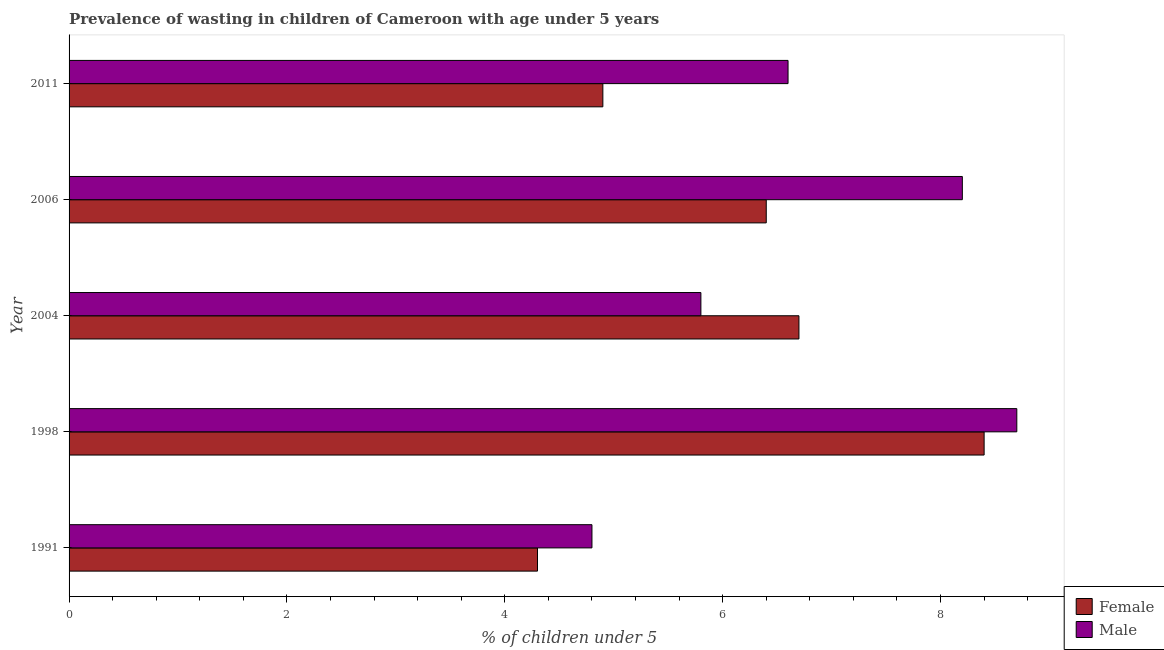How many different coloured bars are there?
Your response must be concise. 2. How many groups of bars are there?
Your answer should be compact. 5. Are the number of bars on each tick of the Y-axis equal?
Your answer should be compact. Yes. How many bars are there on the 5th tick from the top?
Your response must be concise. 2. What is the percentage of undernourished male children in 1998?
Offer a very short reply. 8.7. Across all years, what is the maximum percentage of undernourished female children?
Your answer should be very brief. 8.4. Across all years, what is the minimum percentage of undernourished female children?
Keep it short and to the point. 4.3. What is the total percentage of undernourished male children in the graph?
Your answer should be very brief. 34.1. What is the difference between the percentage of undernourished female children in 1991 and that in 2004?
Your response must be concise. -2.4. What is the difference between the percentage of undernourished female children in 1998 and the percentage of undernourished male children in 2006?
Make the answer very short. 0.2. What is the average percentage of undernourished female children per year?
Offer a very short reply. 6.14. What is the ratio of the percentage of undernourished male children in 1991 to that in 2006?
Offer a very short reply. 0.58. Is the percentage of undernourished female children in 1998 less than that in 2011?
Offer a very short reply. No. Is the difference between the percentage of undernourished female children in 1998 and 2004 greater than the difference between the percentage of undernourished male children in 1998 and 2004?
Keep it short and to the point. No. What is the difference between the highest and the second highest percentage of undernourished male children?
Ensure brevity in your answer.  0.5. What is the difference between the highest and the lowest percentage of undernourished male children?
Offer a very short reply. 3.9. Is the sum of the percentage of undernourished male children in 1998 and 2011 greater than the maximum percentage of undernourished female children across all years?
Your answer should be compact. Yes. What does the 1st bar from the top in 1998 represents?
Your response must be concise. Male. What does the 2nd bar from the bottom in 2006 represents?
Your answer should be compact. Male. How many bars are there?
Provide a succinct answer. 10. Are all the bars in the graph horizontal?
Your answer should be very brief. Yes. Are the values on the major ticks of X-axis written in scientific E-notation?
Provide a short and direct response. No. Does the graph contain grids?
Offer a very short reply. No. How many legend labels are there?
Offer a terse response. 2. How are the legend labels stacked?
Give a very brief answer. Vertical. What is the title of the graph?
Give a very brief answer. Prevalence of wasting in children of Cameroon with age under 5 years. What is the label or title of the X-axis?
Offer a terse response.  % of children under 5. What is the label or title of the Y-axis?
Keep it short and to the point. Year. What is the  % of children under 5 of Female in 1991?
Your response must be concise. 4.3. What is the  % of children under 5 of Male in 1991?
Offer a terse response. 4.8. What is the  % of children under 5 in Female in 1998?
Your response must be concise. 8.4. What is the  % of children under 5 in Male in 1998?
Provide a short and direct response. 8.7. What is the  % of children under 5 of Female in 2004?
Your answer should be very brief. 6.7. What is the  % of children under 5 in Male in 2004?
Your response must be concise. 5.8. What is the  % of children under 5 in Female in 2006?
Offer a terse response. 6.4. What is the  % of children under 5 in Male in 2006?
Keep it short and to the point. 8.2. What is the  % of children under 5 of Female in 2011?
Ensure brevity in your answer.  4.9. What is the  % of children under 5 in Male in 2011?
Offer a very short reply. 6.6. Across all years, what is the maximum  % of children under 5 in Female?
Your answer should be compact. 8.4. Across all years, what is the maximum  % of children under 5 of Male?
Your answer should be compact. 8.7. Across all years, what is the minimum  % of children under 5 in Female?
Ensure brevity in your answer.  4.3. Across all years, what is the minimum  % of children under 5 in Male?
Your response must be concise. 4.8. What is the total  % of children under 5 of Female in the graph?
Offer a very short reply. 30.7. What is the total  % of children under 5 of Male in the graph?
Keep it short and to the point. 34.1. What is the difference between the  % of children under 5 of Female in 1991 and that in 1998?
Your answer should be very brief. -4.1. What is the difference between the  % of children under 5 of Female in 1991 and that in 2004?
Ensure brevity in your answer.  -2.4. What is the difference between the  % of children under 5 in Male in 1991 and that in 2004?
Offer a very short reply. -1. What is the difference between the  % of children under 5 in Male in 1991 and that in 2006?
Offer a terse response. -3.4. What is the difference between the  % of children under 5 of Female in 1991 and that in 2011?
Offer a terse response. -0.6. What is the difference between the  % of children under 5 of Male in 1991 and that in 2011?
Provide a short and direct response. -1.8. What is the difference between the  % of children under 5 of Female in 1998 and that in 2004?
Offer a terse response. 1.7. What is the difference between the  % of children under 5 in Male in 1998 and that in 2004?
Make the answer very short. 2.9. What is the difference between the  % of children under 5 of Female in 1998 and that in 2006?
Keep it short and to the point. 2. What is the difference between the  % of children under 5 in Female in 1998 and that in 2011?
Provide a succinct answer. 3.5. What is the difference between the  % of children under 5 in Male in 1998 and that in 2011?
Give a very brief answer. 2.1. What is the difference between the  % of children under 5 of Female in 2004 and that in 2006?
Your answer should be very brief. 0.3. What is the difference between the  % of children under 5 of Male in 2004 and that in 2006?
Keep it short and to the point. -2.4. What is the difference between the  % of children under 5 in Male in 2004 and that in 2011?
Ensure brevity in your answer.  -0.8. What is the difference between the  % of children under 5 of Female in 1991 and the  % of children under 5 of Male in 1998?
Keep it short and to the point. -4.4. What is the difference between the  % of children under 5 in Female in 1998 and the  % of children under 5 in Male in 2004?
Give a very brief answer. 2.6. What is the difference between the  % of children under 5 of Female in 1998 and the  % of children under 5 of Male in 2006?
Your answer should be very brief. 0.2. What is the difference between the  % of children under 5 of Female in 1998 and the  % of children under 5 of Male in 2011?
Your response must be concise. 1.8. What is the difference between the  % of children under 5 of Female in 2006 and the  % of children under 5 of Male in 2011?
Offer a very short reply. -0.2. What is the average  % of children under 5 in Female per year?
Provide a short and direct response. 6.14. What is the average  % of children under 5 of Male per year?
Your response must be concise. 6.82. In the year 2004, what is the difference between the  % of children under 5 in Female and  % of children under 5 in Male?
Your answer should be very brief. 0.9. In the year 2011, what is the difference between the  % of children under 5 in Female and  % of children under 5 in Male?
Offer a very short reply. -1.7. What is the ratio of the  % of children under 5 in Female in 1991 to that in 1998?
Provide a succinct answer. 0.51. What is the ratio of the  % of children under 5 in Male in 1991 to that in 1998?
Your answer should be compact. 0.55. What is the ratio of the  % of children under 5 of Female in 1991 to that in 2004?
Make the answer very short. 0.64. What is the ratio of the  % of children under 5 of Male in 1991 to that in 2004?
Give a very brief answer. 0.83. What is the ratio of the  % of children under 5 of Female in 1991 to that in 2006?
Give a very brief answer. 0.67. What is the ratio of the  % of children under 5 in Male in 1991 to that in 2006?
Offer a very short reply. 0.59. What is the ratio of the  % of children under 5 of Female in 1991 to that in 2011?
Provide a succinct answer. 0.88. What is the ratio of the  % of children under 5 in Male in 1991 to that in 2011?
Offer a terse response. 0.73. What is the ratio of the  % of children under 5 in Female in 1998 to that in 2004?
Offer a very short reply. 1.25. What is the ratio of the  % of children under 5 in Female in 1998 to that in 2006?
Your answer should be compact. 1.31. What is the ratio of the  % of children under 5 of Male in 1998 to that in 2006?
Provide a short and direct response. 1.06. What is the ratio of the  % of children under 5 of Female in 1998 to that in 2011?
Your response must be concise. 1.71. What is the ratio of the  % of children under 5 of Male in 1998 to that in 2011?
Give a very brief answer. 1.32. What is the ratio of the  % of children under 5 of Female in 2004 to that in 2006?
Give a very brief answer. 1.05. What is the ratio of the  % of children under 5 of Male in 2004 to that in 2006?
Your answer should be very brief. 0.71. What is the ratio of the  % of children under 5 of Female in 2004 to that in 2011?
Make the answer very short. 1.37. What is the ratio of the  % of children under 5 in Male in 2004 to that in 2011?
Ensure brevity in your answer.  0.88. What is the ratio of the  % of children under 5 in Female in 2006 to that in 2011?
Your answer should be compact. 1.31. What is the ratio of the  % of children under 5 in Male in 2006 to that in 2011?
Make the answer very short. 1.24. What is the difference between the highest and the lowest  % of children under 5 in Male?
Ensure brevity in your answer.  3.9. 